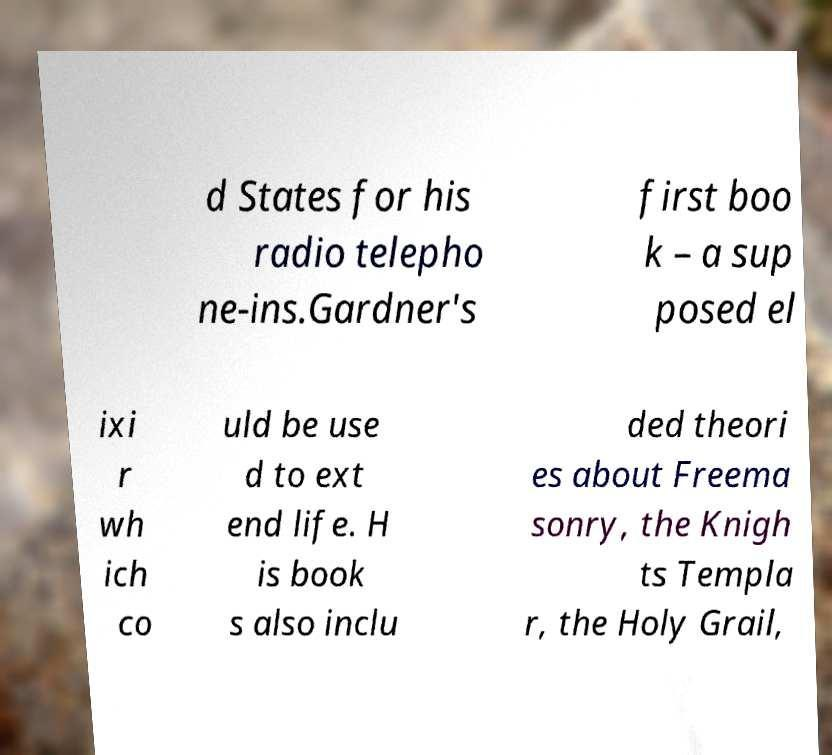Please identify and transcribe the text found in this image. d States for his radio telepho ne-ins.Gardner's first boo k – a sup posed el ixi r wh ich co uld be use d to ext end life. H is book s also inclu ded theori es about Freema sonry, the Knigh ts Templa r, the Holy Grail, 